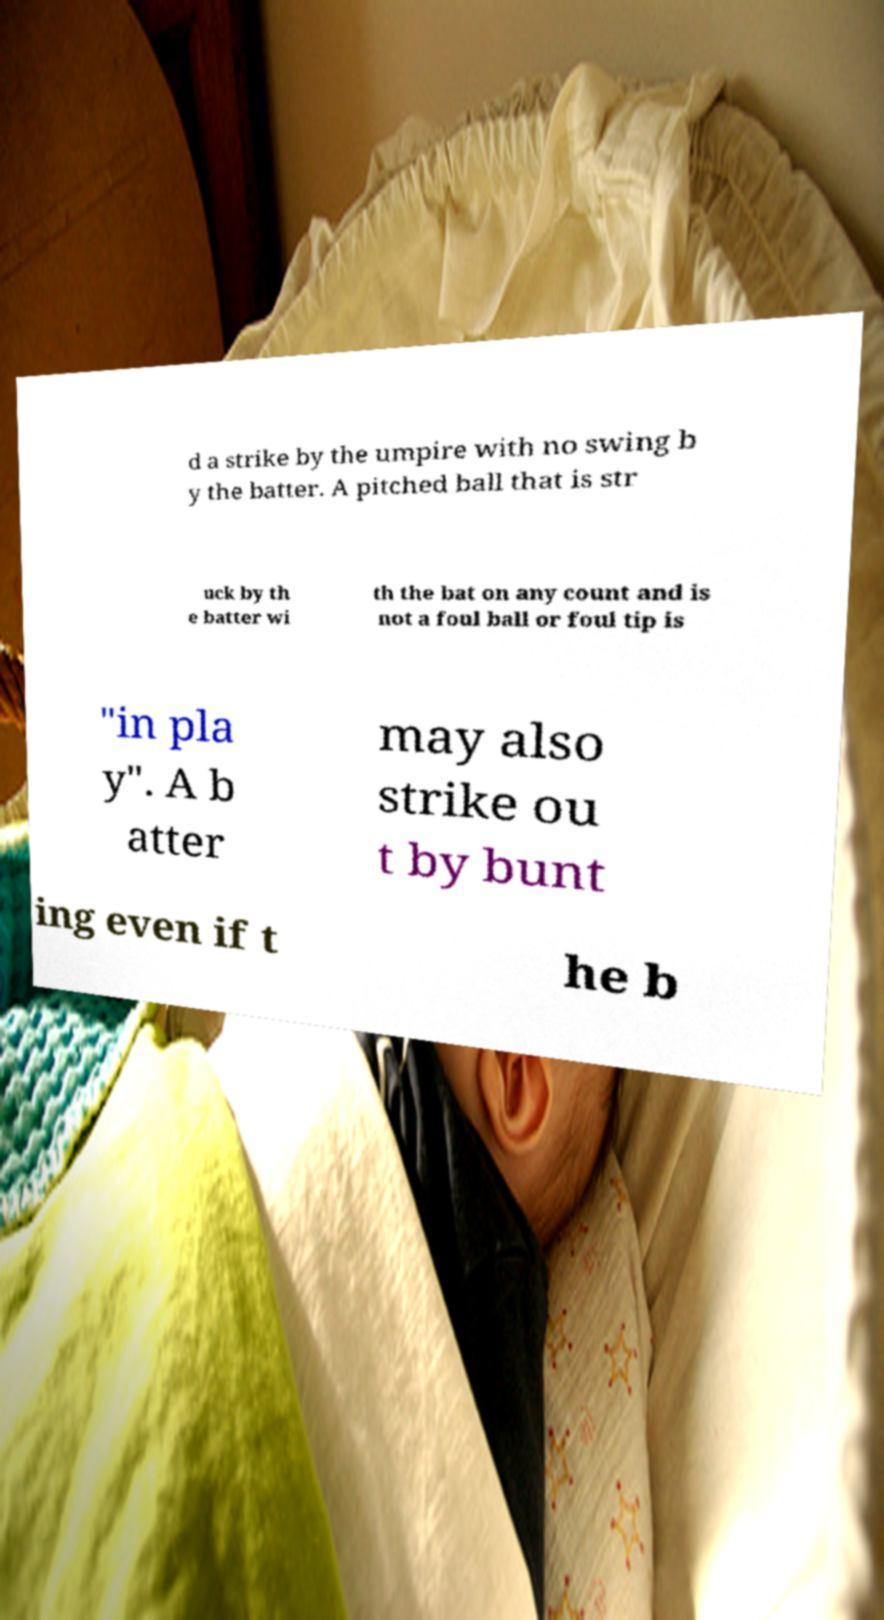For documentation purposes, I need the text within this image transcribed. Could you provide that? d a strike by the umpire with no swing b y the batter. A pitched ball that is str uck by th e batter wi th the bat on any count and is not a foul ball or foul tip is "in pla y". A b atter may also strike ou t by bunt ing even if t he b 